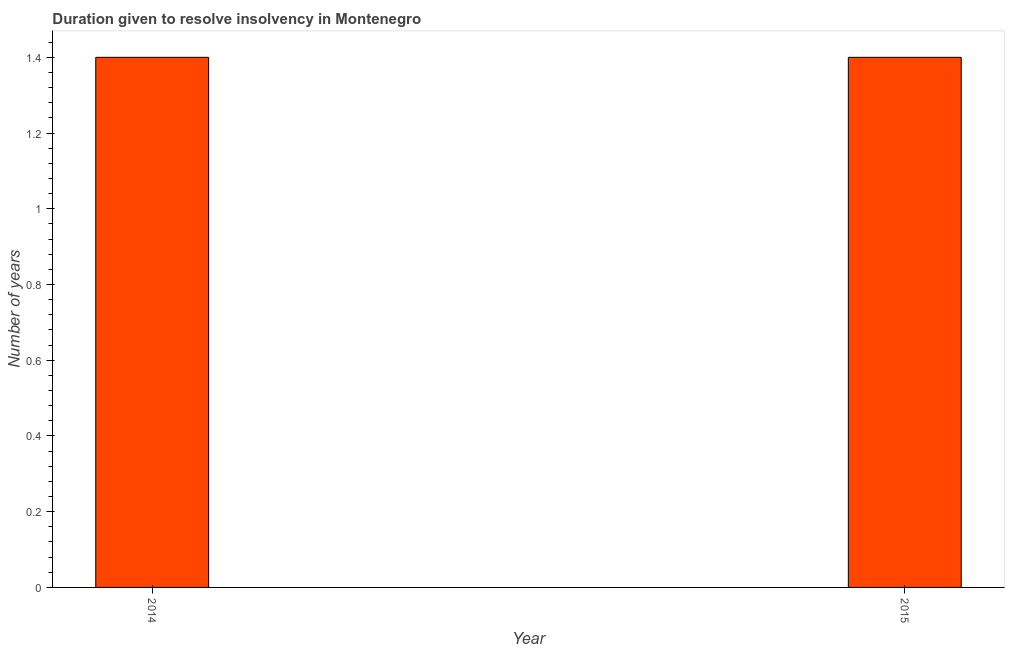Does the graph contain grids?
Give a very brief answer. No. What is the title of the graph?
Offer a very short reply. Duration given to resolve insolvency in Montenegro. What is the label or title of the X-axis?
Keep it short and to the point. Year. What is the label or title of the Y-axis?
Ensure brevity in your answer.  Number of years. Across all years, what is the minimum number of years to resolve insolvency?
Make the answer very short. 1.4. In which year was the number of years to resolve insolvency maximum?
Ensure brevity in your answer.  2014. In which year was the number of years to resolve insolvency minimum?
Your response must be concise. 2014. What is the difference between the number of years to resolve insolvency in 2014 and 2015?
Your response must be concise. 0. What is the average number of years to resolve insolvency per year?
Offer a very short reply. 1.4. What is the median number of years to resolve insolvency?
Provide a short and direct response. 1.4. In how many years, is the number of years to resolve insolvency greater than 0.36 ?
Provide a short and direct response. 2. Is the number of years to resolve insolvency in 2014 less than that in 2015?
Your answer should be compact. No. In how many years, is the number of years to resolve insolvency greater than the average number of years to resolve insolvency taken over all years?
Ensure brevity in your answer.  0. How many bars are there?
Offer a very short reply. 2. What is the difference between two consecutive major ticks on the Y-axis?
Provide a succinct answer. 0.2. What is the Number of years of 2015?
Give a very brief answer. 1.4. What is the difference between the Number of years in 2014 and 2015?
Provide a succinct answer. 0. 